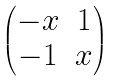Convert formula to latex. <formula><loc_0><loc_0><loc_500><loc_500>\begin{pmatrix} - x & 1 \\ - 1 & x \end{pmatrix}</formula> 